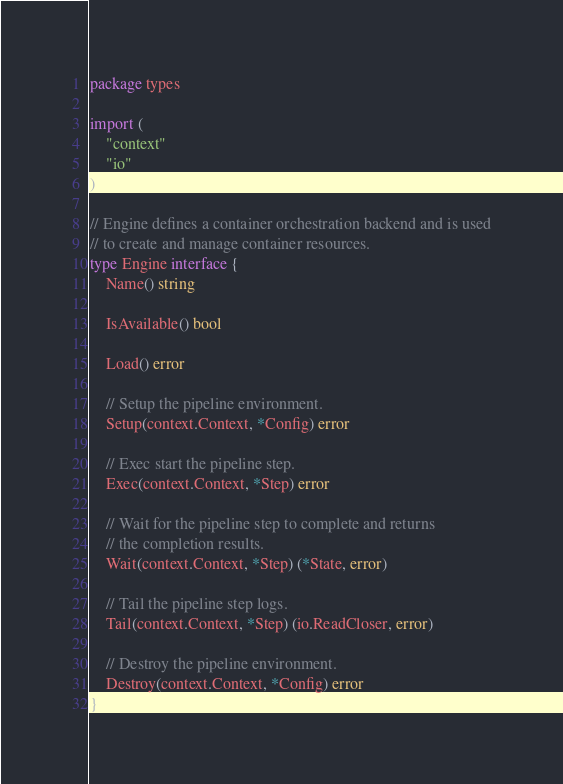<code> <loc_0><loc_0><loc_500><loc_500><_Go_>package types

import (
	"context"
	"io"
)

// Engine defines a container orchestration backend and is used
// to create and manage container resources.
type Engine interface {
	Name() string

	IsAvailable() bool

	Load() error

	// Setup the pipeline environment.
	Setup(context.Context, *Config) error

	// Exec start the pipeline step.
	Exec(context.Context, *Step) error

	// Wait for the pipeline step to complete and returns
	// the completion results.
	Wait(context.Context, *Step) (*State, error)

	// Tail the pipeline step logs.
	Tail(context.Context, *Step) (io.ReadCloser, error)

	// Destroy the pipeline environment.
	Destroy(context.Context, *Config) error
}
</code> 